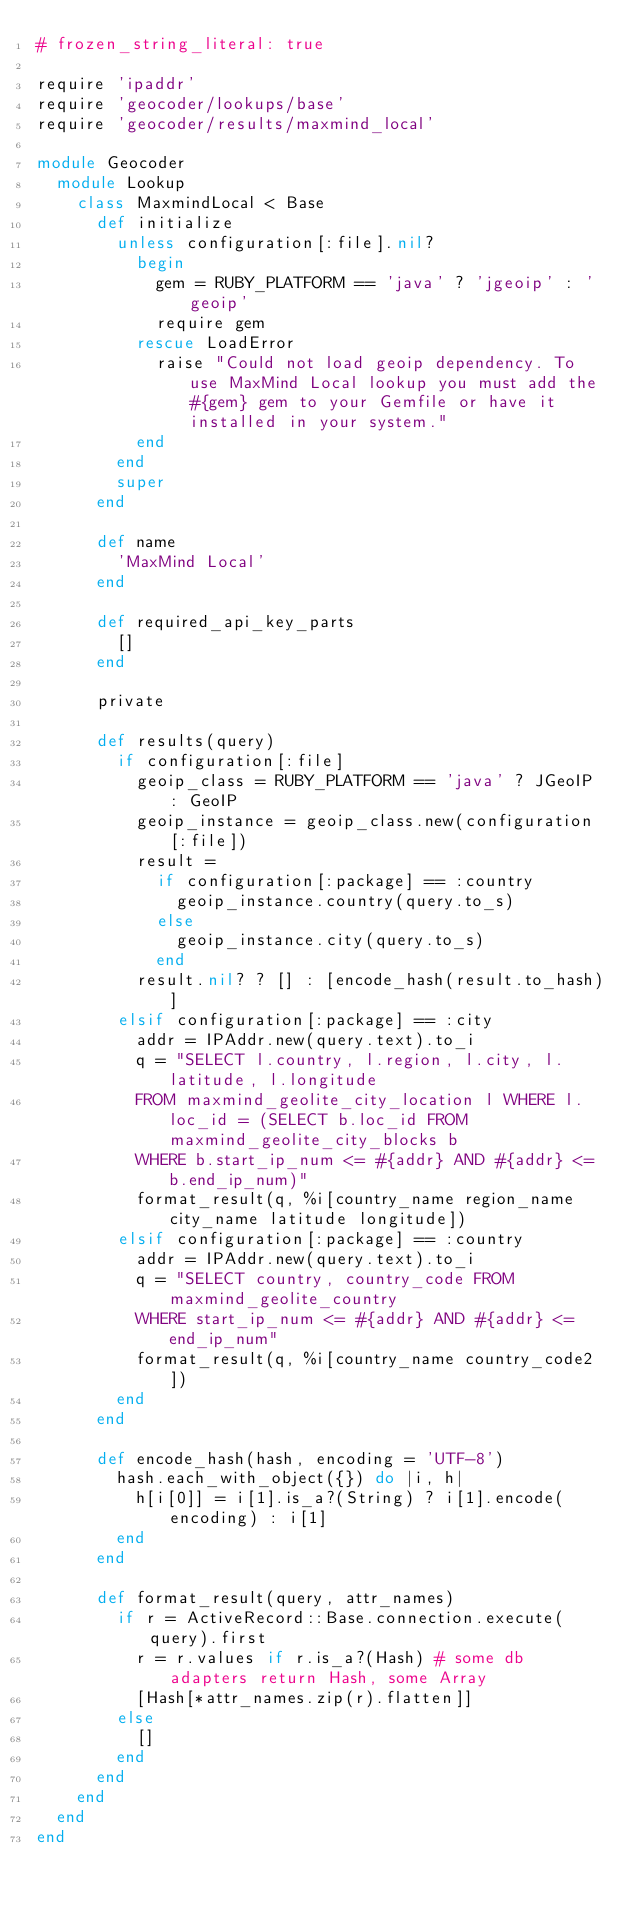Convert code to text. <code><loc_0><loc_0><loc_500><loc_500><_Ruby_># frozen_string_literal: true

require 'ipaddr'
require 'geocoder/lookups/base'
require 'geocoder/results/maxmind_local'

module Geocoder
  module Lookup
    class MaxmindLocal < Base
      def initialize
        unless configuration[:file].nil?
          begin
            gem = RUBY_PLATFORM == 'java' ? 'jgeoip' : 'geoip'
            require gem
          rescue LoadError
            raise "Could not load geoip dependency. To use MaxMind Local lookup you must add the #{gem} gem to your Gemfile or have it installed in your system."
          end
        end
        super
      end

      def name
        'MaxMind Local'
      end

      def required_api_key_parts
        []
      end

      private

      def results(query)
        if configuration[:file]
          geoip_class = RUBY_PLATFORM == 'java' ? JGeoIP : GeoIP
          geoip_instance = geoip_class.new(configuration[:file])
          result =
            if configuration[:package] == :country
              geoip_instance.country(query.to_s)
            else
              geoip_instance.city(query.to_s)
            end
          result.nil? ? [] : [encode_hash(result.to_hash)]
        elsif configuration[:package] == :city
          addr = IPAddr.new(query.text).to_i
          q = "SELECT l.country, l.region, l.city, l.latitude, l.longitude
          FROM maxmind_geolite_city_location l WHERE l.loc_id = (SELECT b.loc_id FROM maxmind_geolite_city_blocks b
          WHERE b.start_ip_num <= #{addr} AND #{addr} <= b.end_ip_num)"
          format_result(q, %i[country_name region_name city_name latitude longitude])
        elsif configuration[:package] == :country
          addr = IPAddr.new(query.text).to_i
          q = "SELECT country, country_code FROM maxmind_geolite_country
          WHERE start_ip_num <= #{addr} AND #{addr} <= end_ip_num"
          format_result(q, %i[country_name country_code2])
        end
      end

      def encode_hash(hash, encoding = 'UTF-8')
        hash.each_with_object({}) do |i, h|
          h[i[0]] = i[1].is_a?(String) ? i[1].encode(encoding) : i[1]
        end
      end

      def format_result(query, attr_names)
        if r = ActiveRecord::Base.connection.execute(query).first
          r = r.values if r.is_a?(Hash) # some db adapters return Hash, some Array
          [Hash[*attr_names.zip(r).flatten]]
        else
          []
        end
      end
    end
  end
end
</code> 